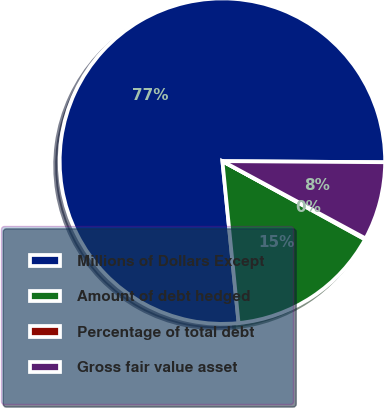Convert chart. <chart><loc_0><loc_0><loc_500><loc_500><pie_chart><fcel>Millions of Dollars Except<fcel>Amount of debt hedged<fcel>Percentage of total debt<fcel>Gross fair value asset<nl><fcel>76.69%<fcel>15.43%<fcel>0.11%<fcel>7.77%<nl></chart> 